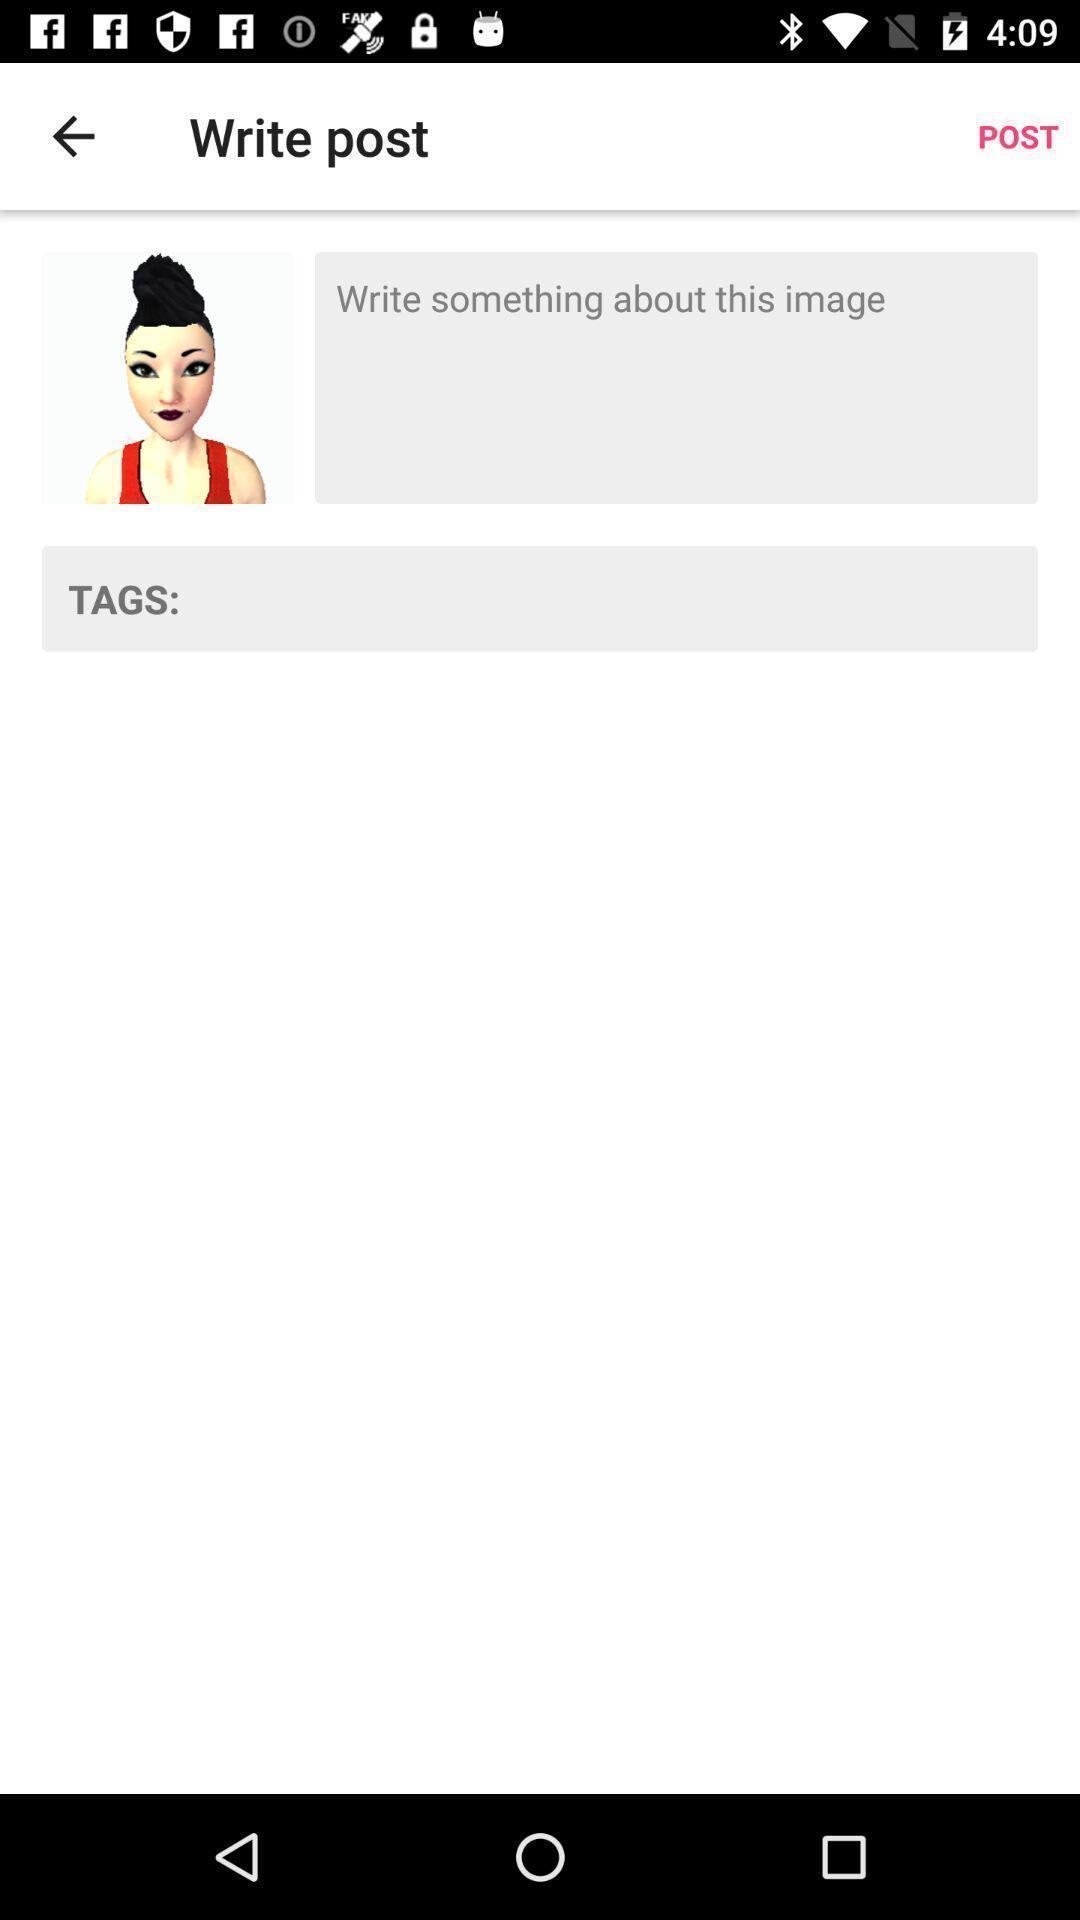Describe the visual elements of this screenshot. Page displaying write post. 